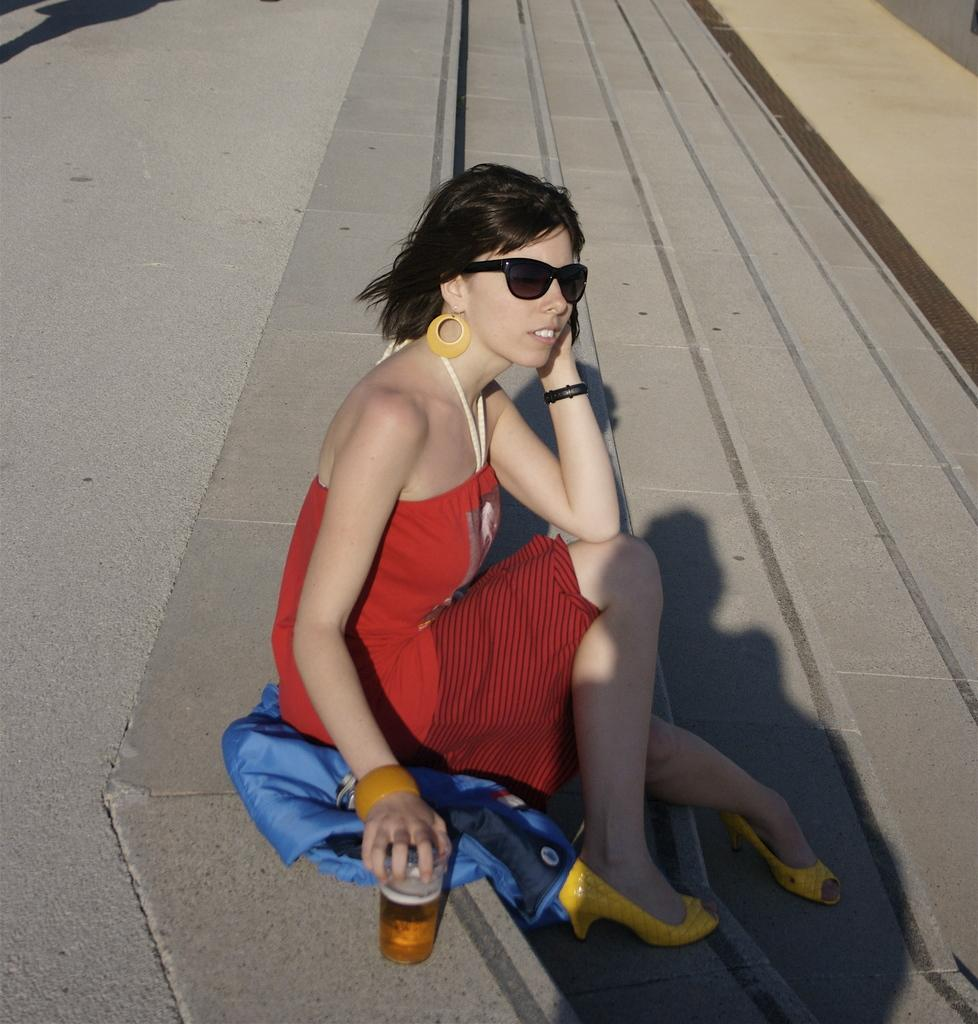What is the woman in the image doing? The woman is sitting on a road. What is the woman holding in the image? The woman is holding a glass. What is the woman wearing in the image? The woman is wearing a beautiful red color dress. What type of pig can be seen in the image? There is no pig present in the image. What kind of stone is the woman sitting on in the image? There is no stone mentioned in the image; the woman is sitting on a road. What acoustics can be heard in the image? The image does not provide any information about sounds or acoustics. 